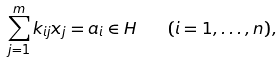<formula> <loc_0><loc_0><loc_500><loc_500>\sum _ { j = 1 } ^ { m } k _ { i j } x _ { j } = a _ { i } \in H \quad ( i = 1 , \dots , n ) ,</formula> 